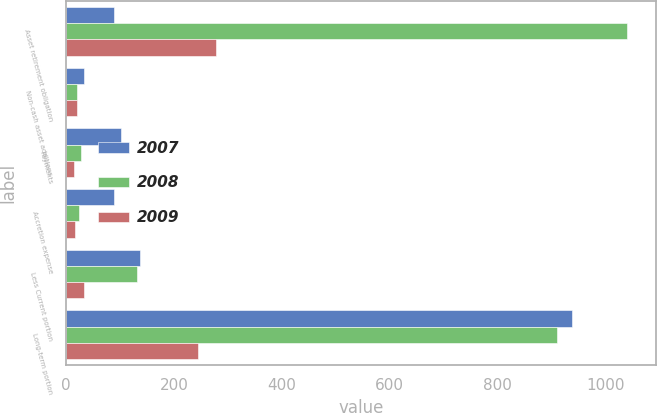<chart> <loc_0><loc_0><loc_500><loc_500><stacked_bar_chart><ecel><fcel>Asset retirement obligation<fcel>Non-cash asset additions<fcel>Payments<fcel>Accretion expense<fcel>Less Current portion<fcel>Long-term portion<nl><fcel>2007<fcel>88.8<fcel>32.5<fcel>100.9<fcel>88.8<fcel>137.5<fcel>937<nl><fcel>2008<fcel>1040.6<fcel>20.5<fcel>27.9<fcel>23.9<fcel>130.6<fcel>910<nl><fcel>2009<fcel>277.7<fcel>19.5<fcel>14.7<fcel>17.1<fcel>32.6<fcel>245.1<nl></chart> 